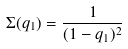Convert formula to latex. <formula><loc_0><loc_0><loc_500><loc_500>\Sigma ( q _ { 1 } ) = \frac { 1 } { ( 1 - q _ { 1 } ) ^ { 2 } }</formula> 